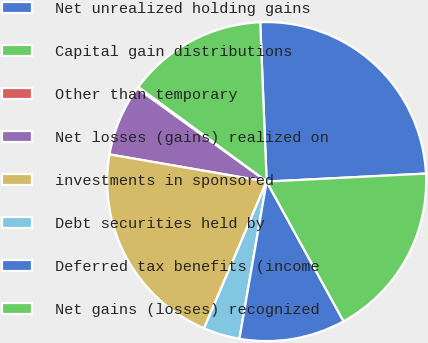Convert chart. <chart><loc_0><loc_0><loc_500><loc_500><pie_chart><fcel>Net unrealized holding gains<fcel>Capital gain distributions<fcel>Other than temporary<fcel>Net losses (gains) realized on<fcel>investments in sponsored<fcel>Debt securities held by<fcel>Deferred tax benefits (income<fcel>Net gains (losses) recognized<nl><fcel>24.84%<fcel>14.26%<fcel>0.16%<fcel>7.21%<fcel>21.31%<fcel>3.69%<fcel>10.74%<fcel>17.79%<nl></chart> 